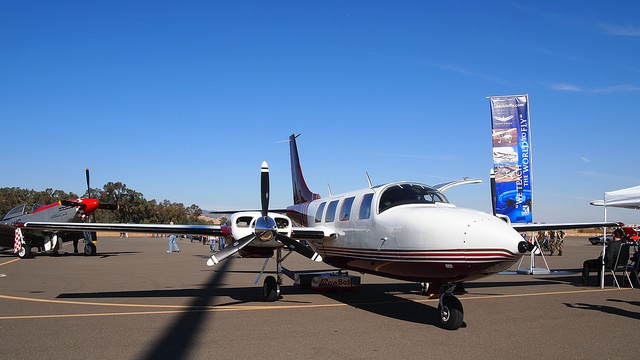Describe the objects in this image and their specific colors. I can see airplane in blue, black, white, darkgray, and gray tones, airplane in blue, black, gray, and white tones, chair in blue, black, gray, lightgray, and darkgray tones, people in blue, black, gray, and maroon tones, and people in blue, black, and gray tones in this image. 